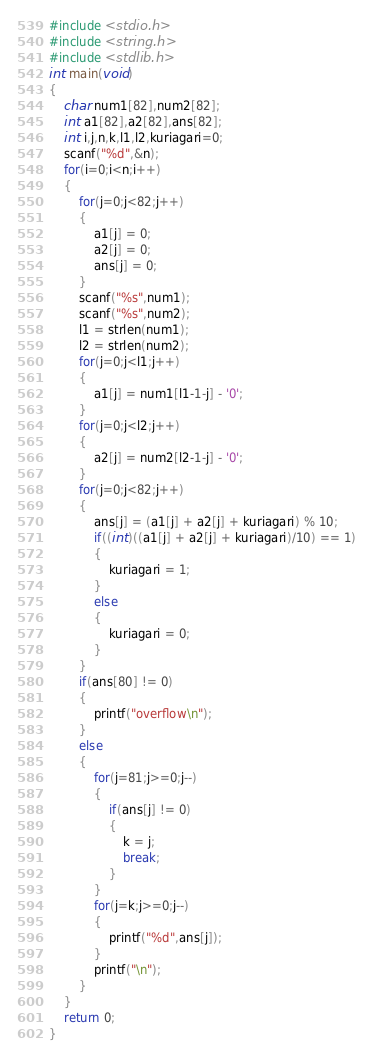Convert code to text. <code><loc_0><loc_0><loc_500><loc_500><_C_>#include <stdio.h>
#include <string.h>
#include <stdlib.h>
int main(void)
{
	char num1[82],num2[82];
	int a1[82],a2[82],ans[82];
	int i,j,n,k,l1,l2,kuriagari=0;
	scanf("%d",&n);
	for(i=0;i<n;i++)
	{
		for(j=0;j<82;j++)
		{
			a1[j] = 0;
			a2[j] = 0;
			ans[j] = 0;
		}
		scanf("%s",num1);
		scanf("%s",num2);
		l1 = strlen(num1);
		l2 = strlen(num2);
		for(j=0;j<l1;j++)
		{
			a1[j] = num1[l1-1-j] - '0';
		}
		for(j=0;j<l2;j++)
		{
			a2[j] = num2[l2-1-j] - '0';
		}
		for(j=0;j<82;j++)
		{
			ans[j] = (a1[j] + a2[j] + kuriagari) % 10;
			if((int)((a1[j] + a2[j] + kuriagari)/10) == 1)
			{
				kuriagari = 1;
			}
			else
			{
				kuriagari = 0;
			}
		}
		if(ans[80] != 0)
		{
			printf("overflow\n");
		}
		else
		{
			for(j=81;j>=0;j--)
			{
				if(ans[j] != 0)
				{
					k = j;
					break;
				}
			}
			for(j=k;j>=0;j--)
			{
				printf("%d",ans[j]);
			}
			printf("\n");
		}
	}
	return 0;
}</code> 